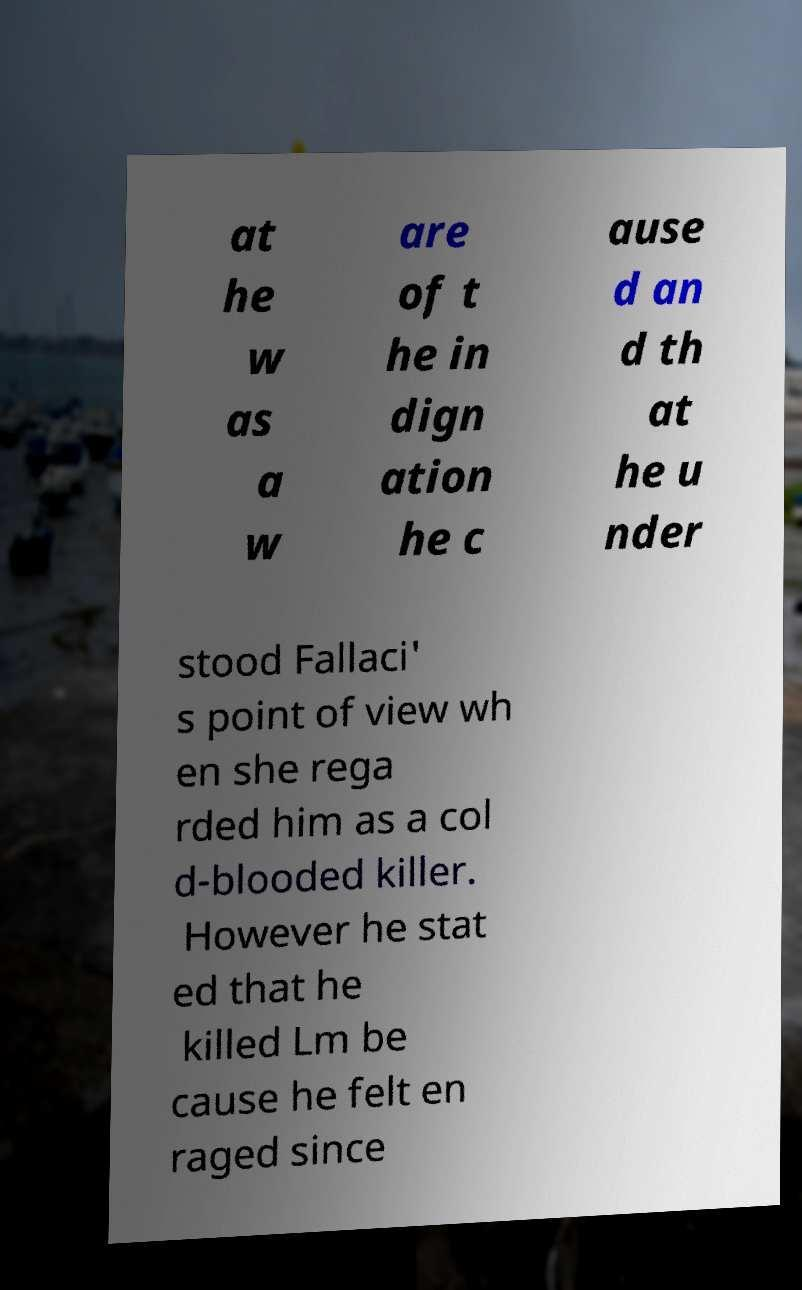Please read and relay the text visible in this image. What does it say? at he w as a w are of t he in dign ation he c ause d an d th at he u nder stood Fallaci' s point of view wh en she rega rded him as a col d-blooded killer. However he stat ed that he killed Lm be cause he felt en raged since 